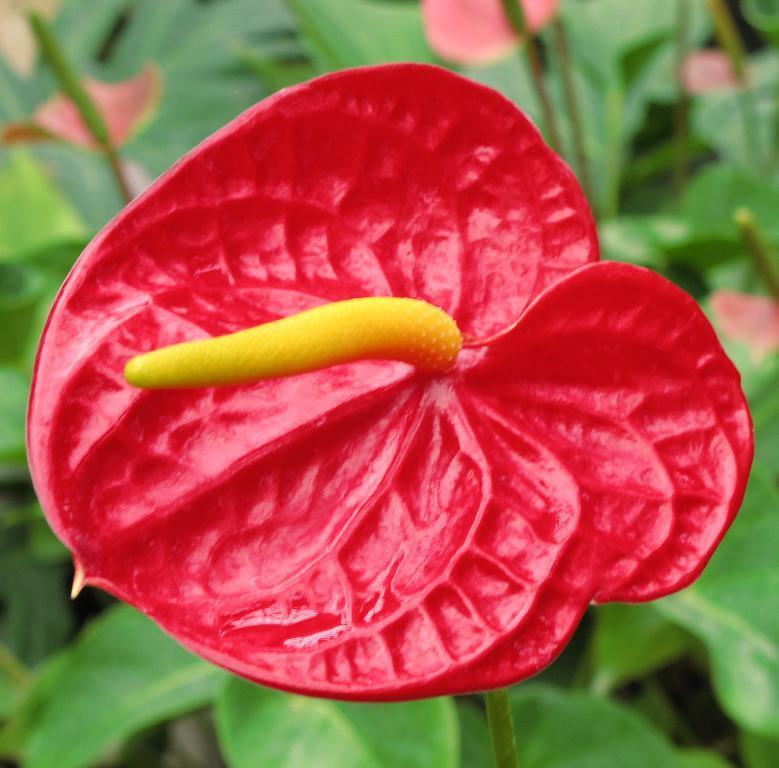Describe this image in one or two sentences. In the center of the image we can see a flower to the stem. We can also see some leaves around it. 